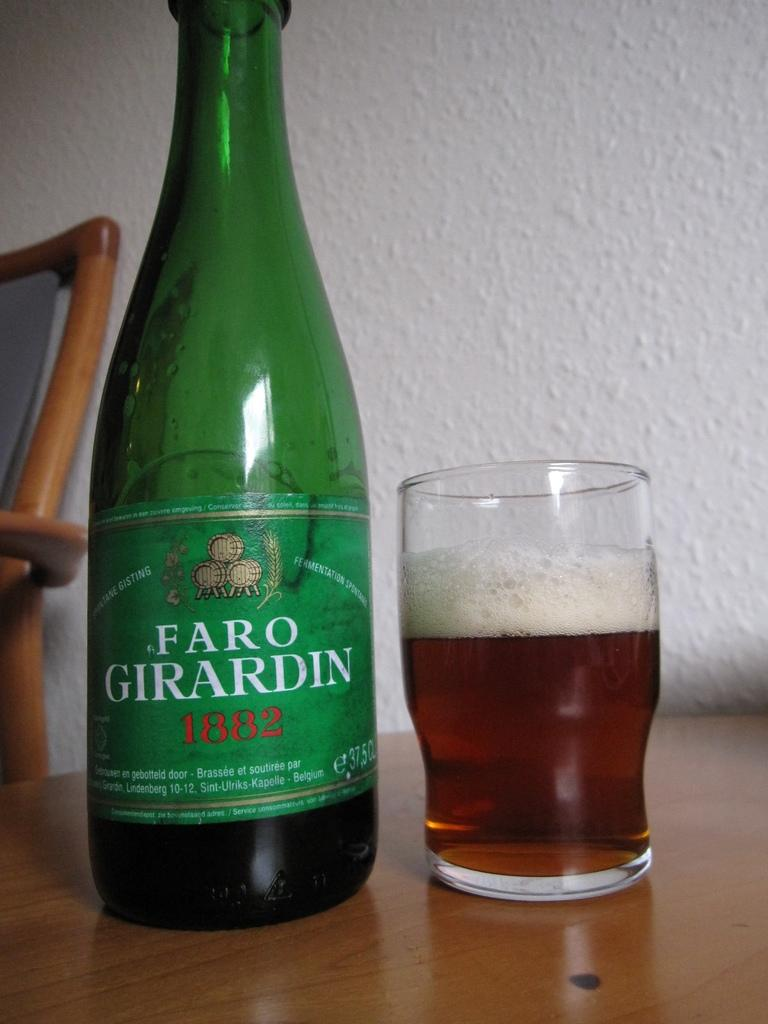What is on the table in the image? There is a bottle and a glass of drink on the table. What else can be seen near the table? There is a chair beside the table. What is the color of the wall in the image? The wall is white in color. How many tickets are on the table in the image? There are no tickets present on the table in the image. What color is the toe of the person sitting on the chair? There is no person or toe visible in the image. 